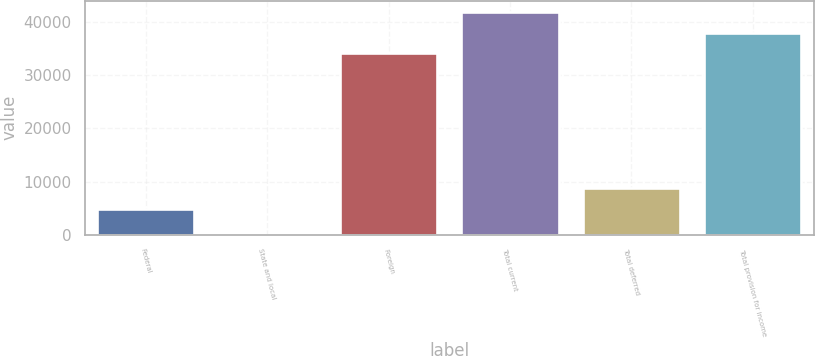Convert chart to OTSL. <chart><loc_0><loc_0><loc_500><loc_500><bar_chart><fcel>Federal<fcel>State and local<fcel>Foreign<fcel>Total current<fcel>Total deferred<fcel>Total provision for income<nl><fcel>4839<fcel>50<fcel>34047<fcel>41824.2<fcel>8727.6<fcel>37935.6<nl></chart> 